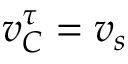<formula> <loc_0><loc_0><loc_500><loc_500>v _ { C } ^ { \tau } = v _ { s }</formula> 